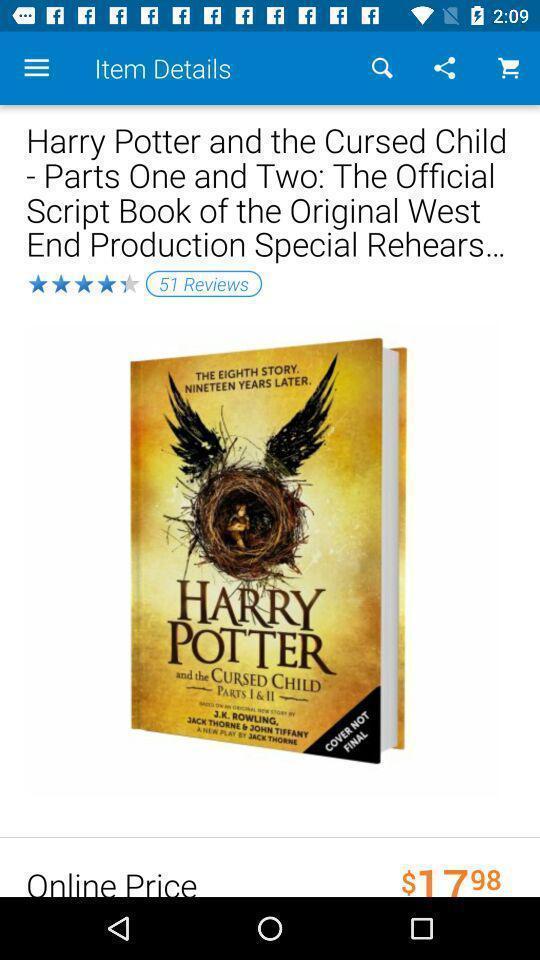Describe the key features of this screenshot. Social app for online shopping. 